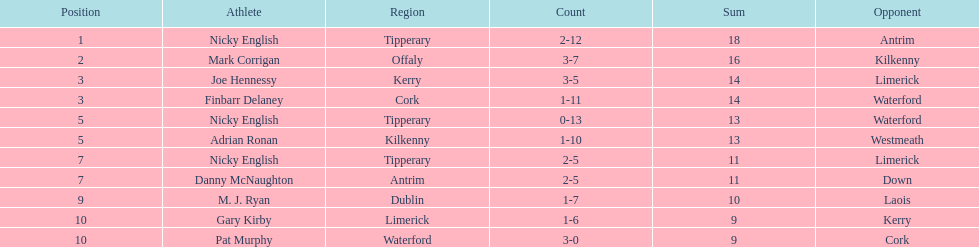Joe hennessy and finbarr delaney both scored how many points? 14. 